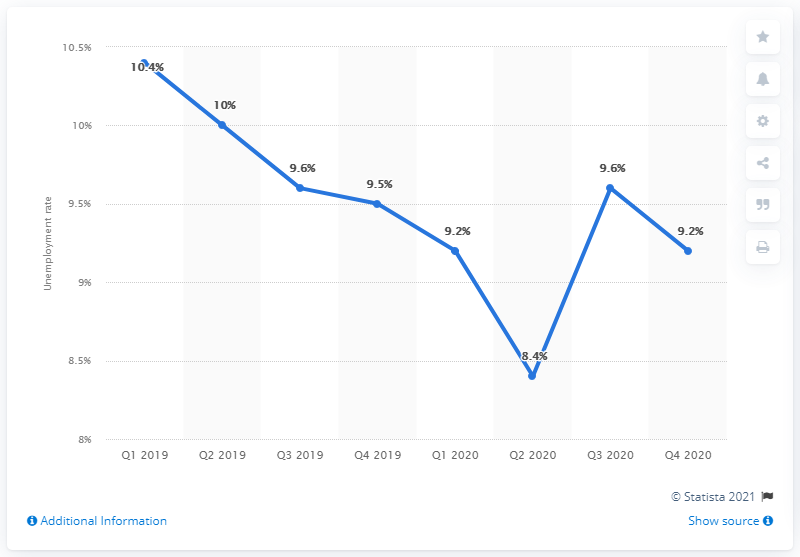List a handful of essential elements in this visual. Italy's unemployment rate in the fourth quarter of 2020 was 9.2%. 